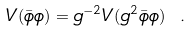Convert formula to latex. <formula><loc_0><loc_0><loc_500><loc_500>V ( \bar { \phi } \phi ) = g ^ { - 2 } V ( g ^ { 2 } \bar { \phi } \phi ) \ .</formula> 